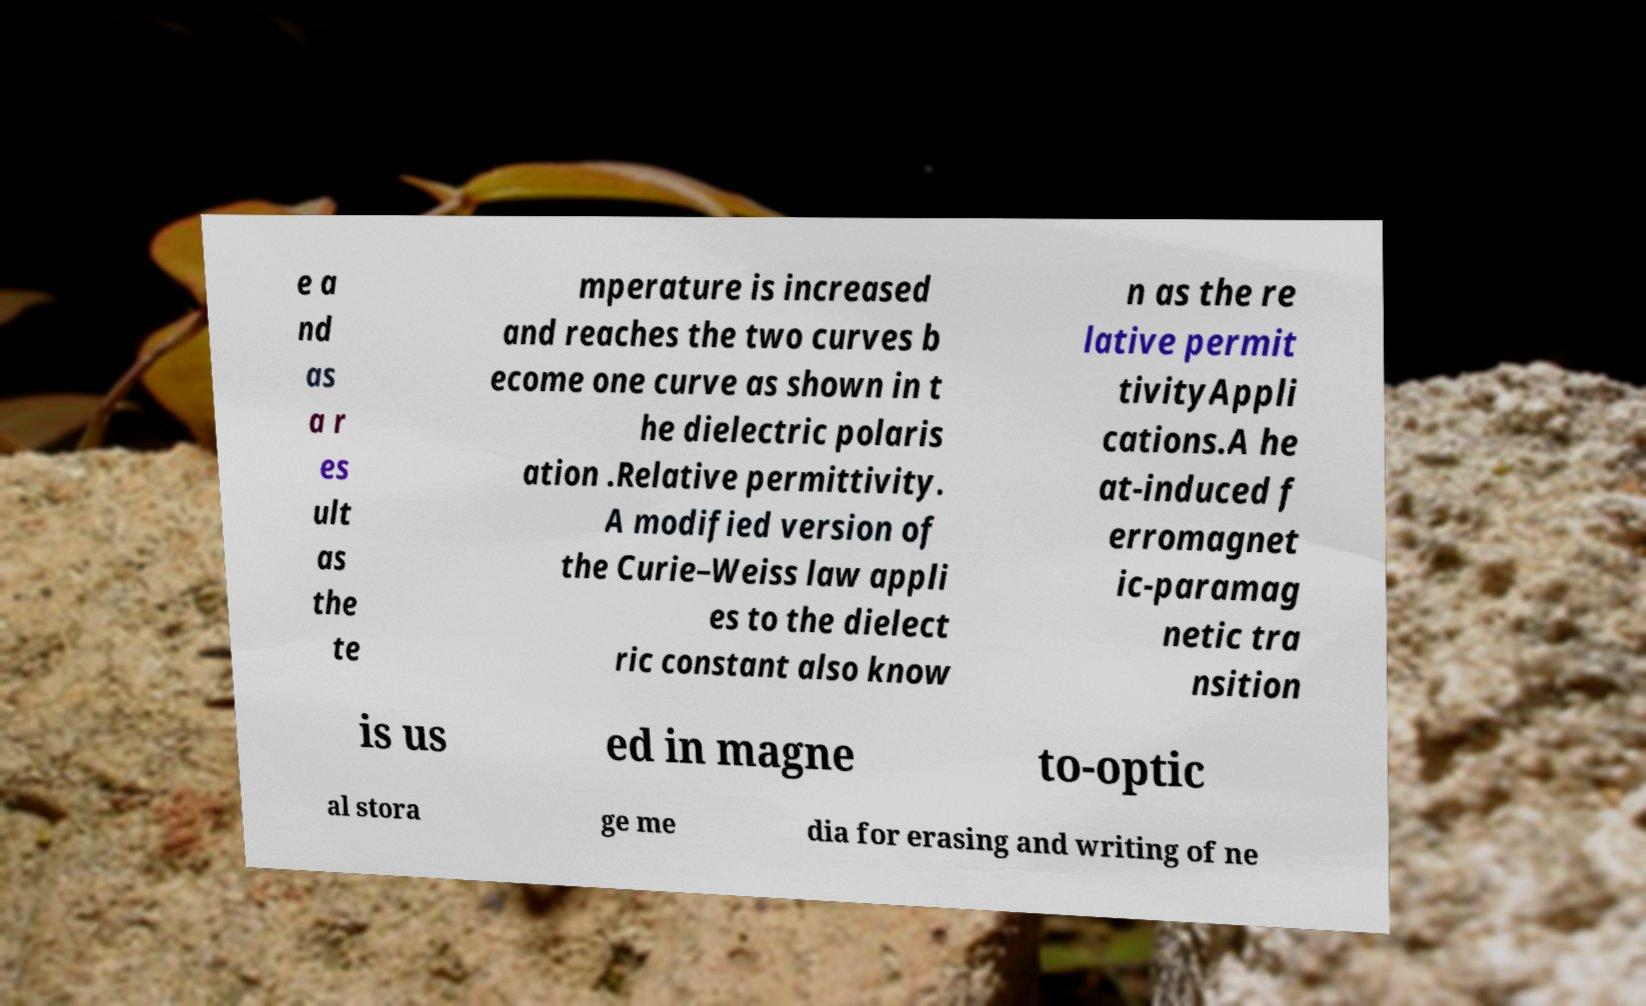Please read and relay the text visible in this image. What does it say? e a nd as a r es ult as the te mperature is increased and reaches the two curves b ecome one curve as shown in t he dielectric polaris ation .Relative permittivity. A modified version of the Curie–Weiss law appli es to the dielect ric constant also know n as the re lative permit tivityAppli cations.A he at-induced f erromagnet ic-paramag netic tra nsition is us ed in magne to-optic al stora ge me dia for erasing and writing of ne 